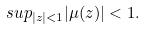<formula> <loc_0><loc_0><loc_500><loc_500>s u p _ { | z | < 1 } | \mu ( z ) | < 1 .</formula> 